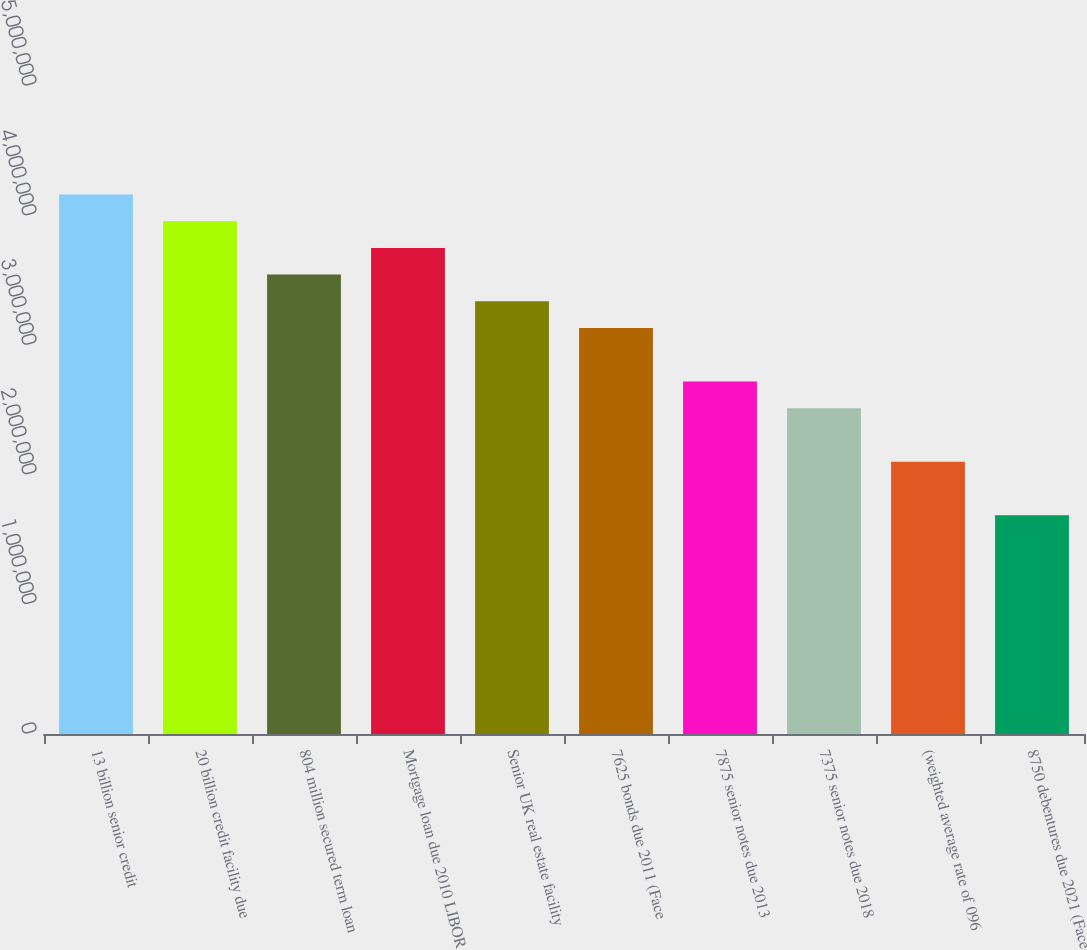Convert chart. <chart><loc_0><loc_0><loc_500><loc_500><bar_chart><fcel>13 billion senior credit<fcel>20 billion credit facility due<fcel>804 million secured term loan<fcel>Mortgage loan due 2010 LIBOR<fcel>Senior UK real estate facility<fcel>7625 bonds due 2011 (Face<fcel>7875 senior notes due 2013<fcel>7375 senior notes due 2018<fcel>(weighted average rate of 096<fcel>8750 debentures due 2021 (Face<nl><fcel>4.16321e+06<fcel>3.957e+06<fcel>3.54458e+06<fcel>3.75079e+06<fcel>3.33837e+06<fcel>3.13216e+06<fcel>2.71974e+06<fcel>2.51352e+06<fcel>2.1011e+06<fcel>1.68868e+06<nl></chart> 